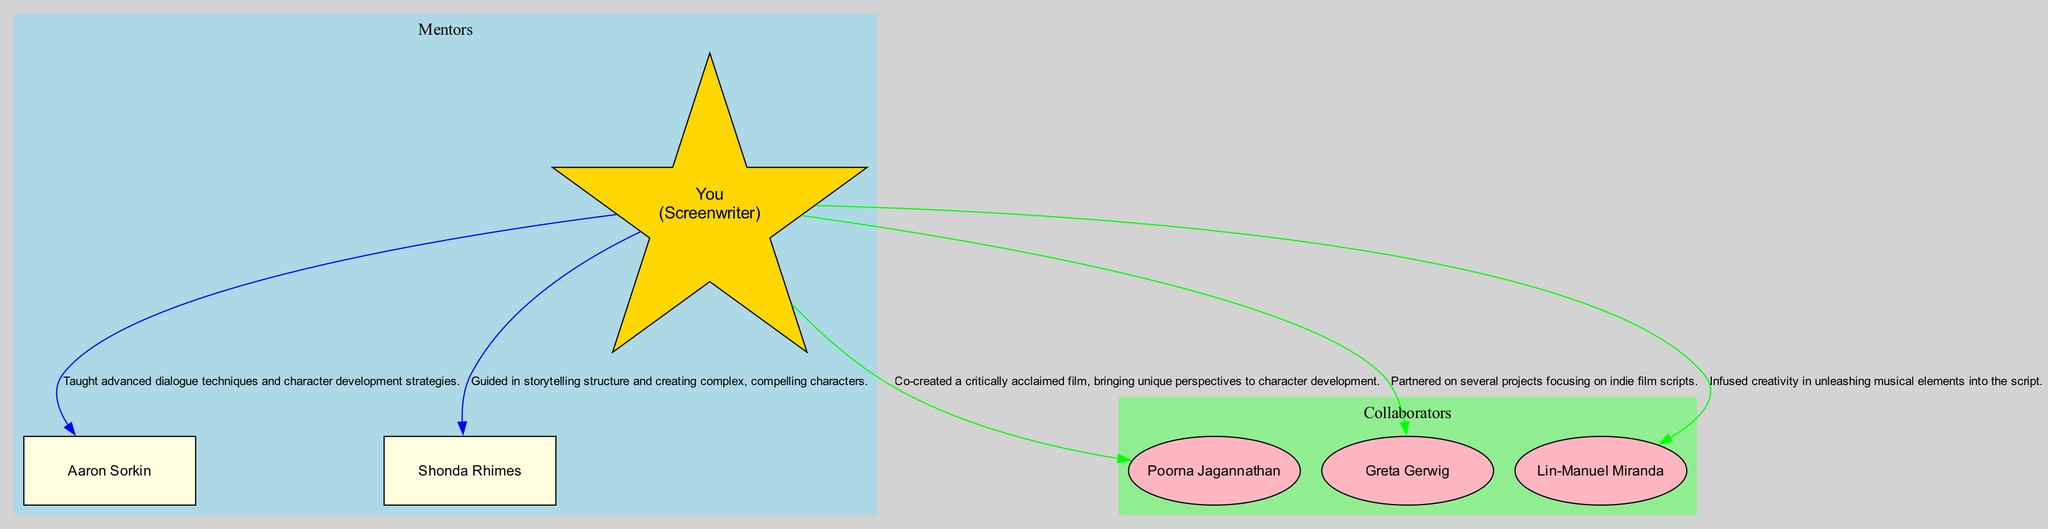What is the name of your key collaborator? The diagram identifies "Poorna Jagannathan" as the key collaborator who co-created a critically acclaimed film with you. This directly corresponds to the label in the node for collaborators.
Answer: Poorna Jagannathan How many mentors are listed in the diagram? The diagram shows a total of 2 mentors, indicated by the number of nodes present in the mentors' cluster. This can be counted visually.
Answer: 2 Which mentor provided guidance on storytelling structure? The edge connecting you to "Shonda Rhimes" mentions her influence in storytelling structure and creating complex characters. Thus, she is the mentor who provided guidance in storytelling structure.
Answer: Shonda Rhimes What project did you work on with Greta Gerwig? In the collaborators' section, "Co-authored a Play" is listed as one of the projects you worked on with Greta Gerwig. This is directly stated in the project details associated with her node.
Answer: Co-authored a Play Who influenced you with advanced dialogue techniques? The edge leading from you to "Aaron Sorkin" describes his influence as teaching advanced dialogue techniques, thus identifying him as the relevant mentor for this aspect.
Answer: Aaron Sorkin How many projects are associated with Poorna Jagannathan? The projects related to Poorna Jagannathan listed in the diagram are "Critically Acclaimed Film" and "Upcoming Theatrical Project." Counting these provides the answer.
Answer: 2 What color represents the mentors in the diagram? The subgraph for mentors is filled with the color light blue, which can be identified by looking at the subgraph's attributes in the diagram.
Answer: Light Blue Which collaborator is associated with musical screenplay development? The diagram associates "Lin-Manuel Miranda" with the project "Musical Screenplay Development," mentioned in the edge connecting him to you. Thus, he is the collaborator related to this aspect.
Answer: Lin-Manuel Miranda What is the relationship between you and Aaron Sorkin? The diagram indicates a direct edge labeled "Mentor" connecting you to Aaron Sorkin, establishing the nature of your relationship as mentor-mentee.
Answer: Mentor 